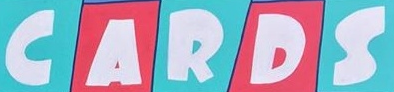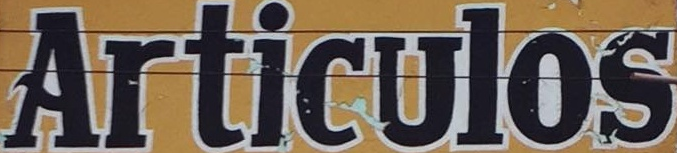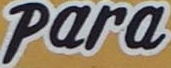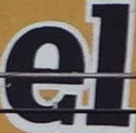What words can you see in these images in sequence, separated by a semicolon? CARDS; Articulos; Para; el 